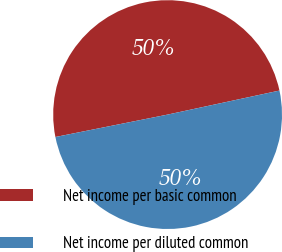Convert chart. <chart><loc_0><loc_0><loc_500><loc_500><pie_chart><fcel>Net income per basic common<fcel>Net income per diluted common<nl><fcel>49.77%<fcel>50.23%<nl></chart> 